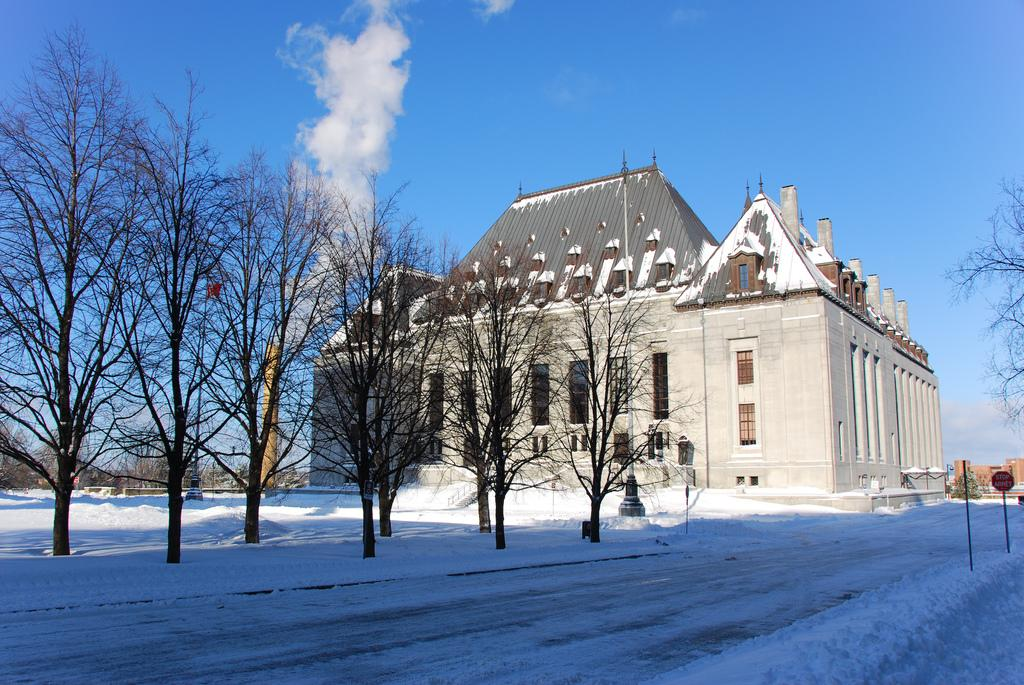What is the condition of the road in the image? The road in the image is covered with snow. What is the state of the trees in the image? The trees in the image are dry. What type of building can be seen in the image? There is a stone building in the image. What structure is present in addition to the stone building? There is a tower in the image. What can be seen coming from the tower or building? Smoke is visible in the image. What objects are present on the ground in the image? There are boards in the image. What can be seen in the sky in the background of the image? The sky in the background is blue with clouds. What type of mint can be seen growing near the stone building in the image? There is no mint present in the image. Can you tell me how many cats are sitting on the boards in the image? There are no cats present in the image. 